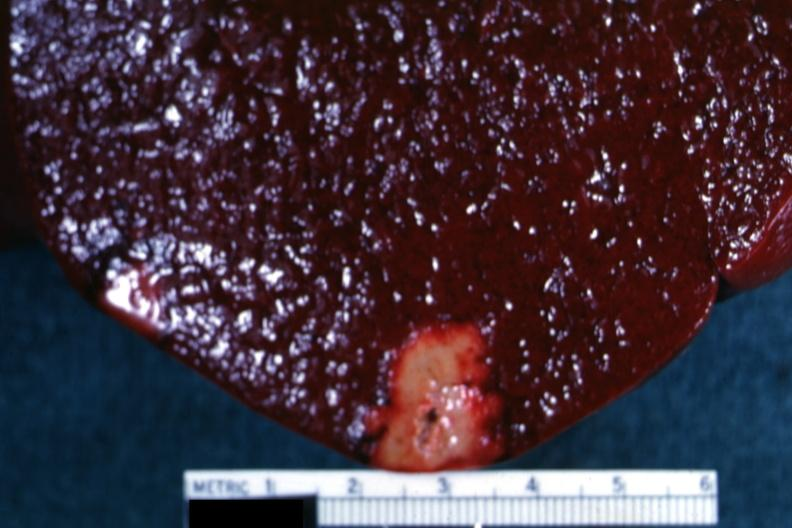s autopsy present?
Answer the question using a single word or phrase. No 